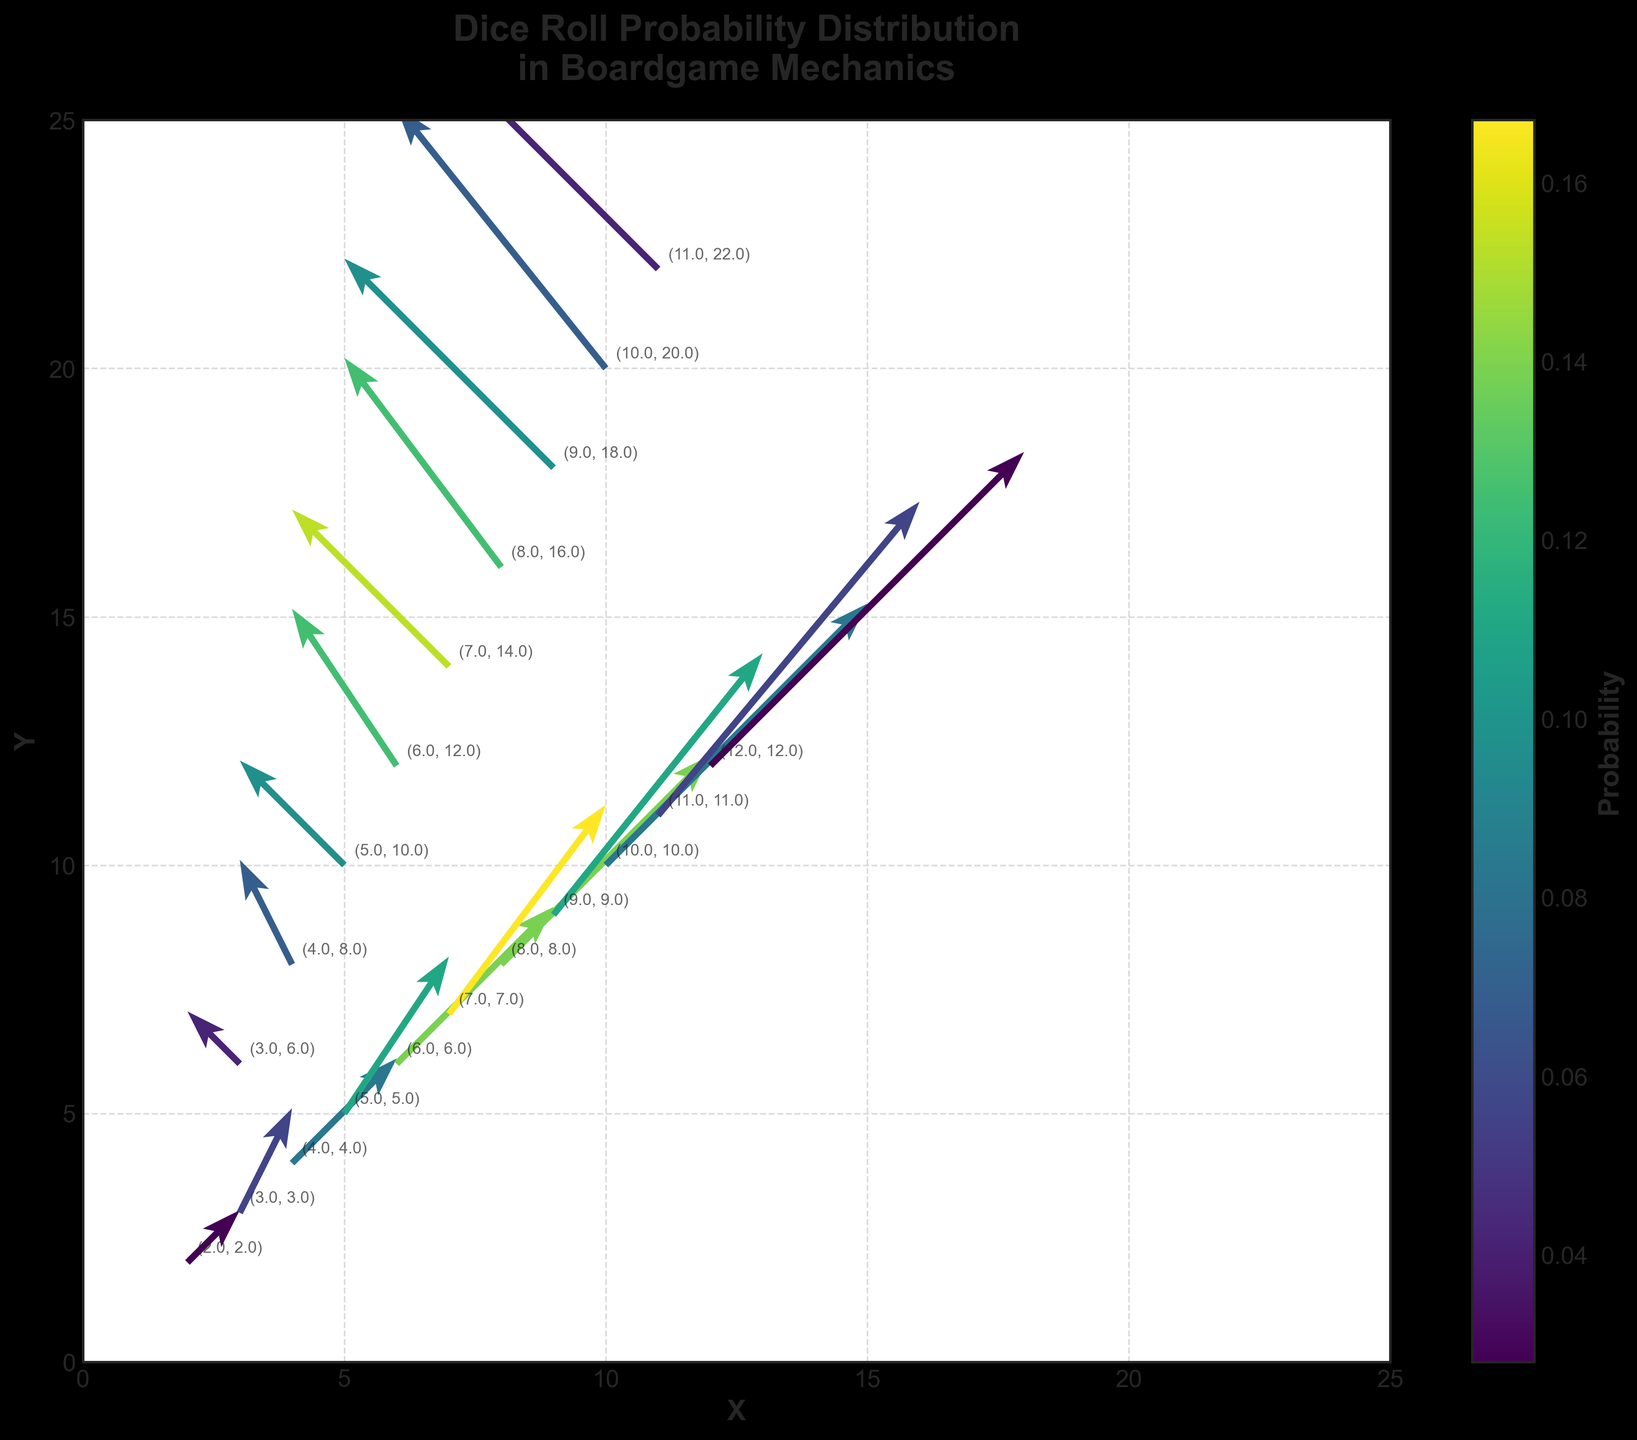What is the title of the plot? The title of the plot is displayed prominently at the top of the quiver plot. It reads 'Dice Roll Probability Distribution in Boardgame Mechanics'.
Answer: Dice Roll Probability Distribution in Boardgame Mechanics What are the labels for the x-axis and y-axis? The labels for the x-axis and y-axis can be found along the respective axes. The x-axis is labeled 'X' and the y-axis is labeled 'Y', both in bold font.
Answer: X and Y What is the colormap used to indicate probability values? The colormap used to indicate probability values is a gradient ranging from blue to yellow-green, specified by the 'viridis' colormap.
Answer: viridis Which data point has the highest probability? To find the data point with the highest probability, look at the quiver arrows colored with the most intense color (yellow-green). We find that the data point at (7,7) with (u=3, v=4) has the highest probability of 0.167.
Answer: (7,7) What is the median probability value among the data points? To find the median probability value, first list all probability values: 0.028, 0.028, 0.042, 0.042, 0.056, 0.056, 0.069, 0.069, 0.083, 0.083, 0.097, 0.097, 0.111, 0.111, 0.125, 0.125, 0.139, 0.139, 0.153, 0.167. The median value, being in the middle, is the average of the 10th and 11th values: (0.083 + 0.097) / 2 = 0.09.
Answer: 0.09 Which data points have the lowest probability, and what is their value? To find the data points with the lowest probability, look for the most subdued color, which corresponds to a probability of 0.028. The data points with this probability are (2,2) and (12,12).
Answer: (2,2) and (12,12) How does the probability value change as the arrows move from (2,2) to (7,7)? Observing the color gradient, you notice that the probability values increase as arrows move from (2,2) to (7,7). The actual probabilities are as follows: 0.028 at (2,2), 0.056 at (3,3), 0.083 at (4,4), 0.111 at (5,5), 0.139 at (6,6), and 0.167 at (7,7).
Answer: They increase Compare the probabilities of the points (3,6) and (10,20). Which one is higher? Checking the annotated data points, (3,6) has a probability of 0.042 and (10,20) has a probability of 0.069. Between these, (10,20) has the higher probability.
Answer: (10,20) What is the range of the probability values in the plot? To find the range, identify the minimum and maximum probability values. The minimum probability is 0.028, and the maximum is 0.167. The range is calculated as 0.167 - 0.028 = 0.139.
Answer: 0.139 Does the plot show any symmetric patterns? If yes, describe one. The plot shows a symmetric pattern along the central diagonal from (7,7). Arrows on both sides of this diagonal have corresponding arrows in opposing directions but similar magnitudes, e.g., (2,2) and (12,12) or (3,6) and (10,20).
Answer: Yes, along the central diagonal (7,7) 